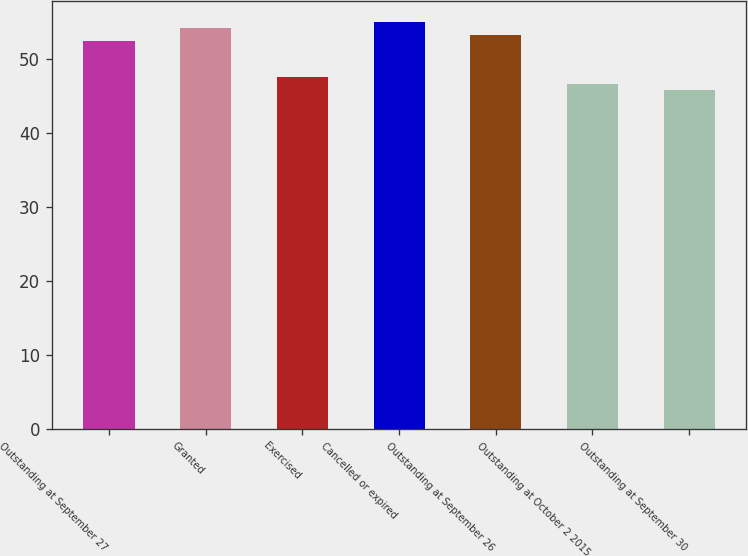Convert chart to OTSL. <chart><loc_0><loc_0><loc_500><loc_500><bar_chart><fcel>Outstanding at September 27<fcel>Granted<fcel>Exercised<fcel>Cancelled or expired<fcel>Outstanding at September 26<fcel>Outstanding at October 2 2015<fcel>Outstanding at September 30<nl><fcel>52.33<fcel>54.11<fcel>47.45<fcel>54.99<fcel>53.23<fcel>46.57<fcel>45.69<nl></chart> 